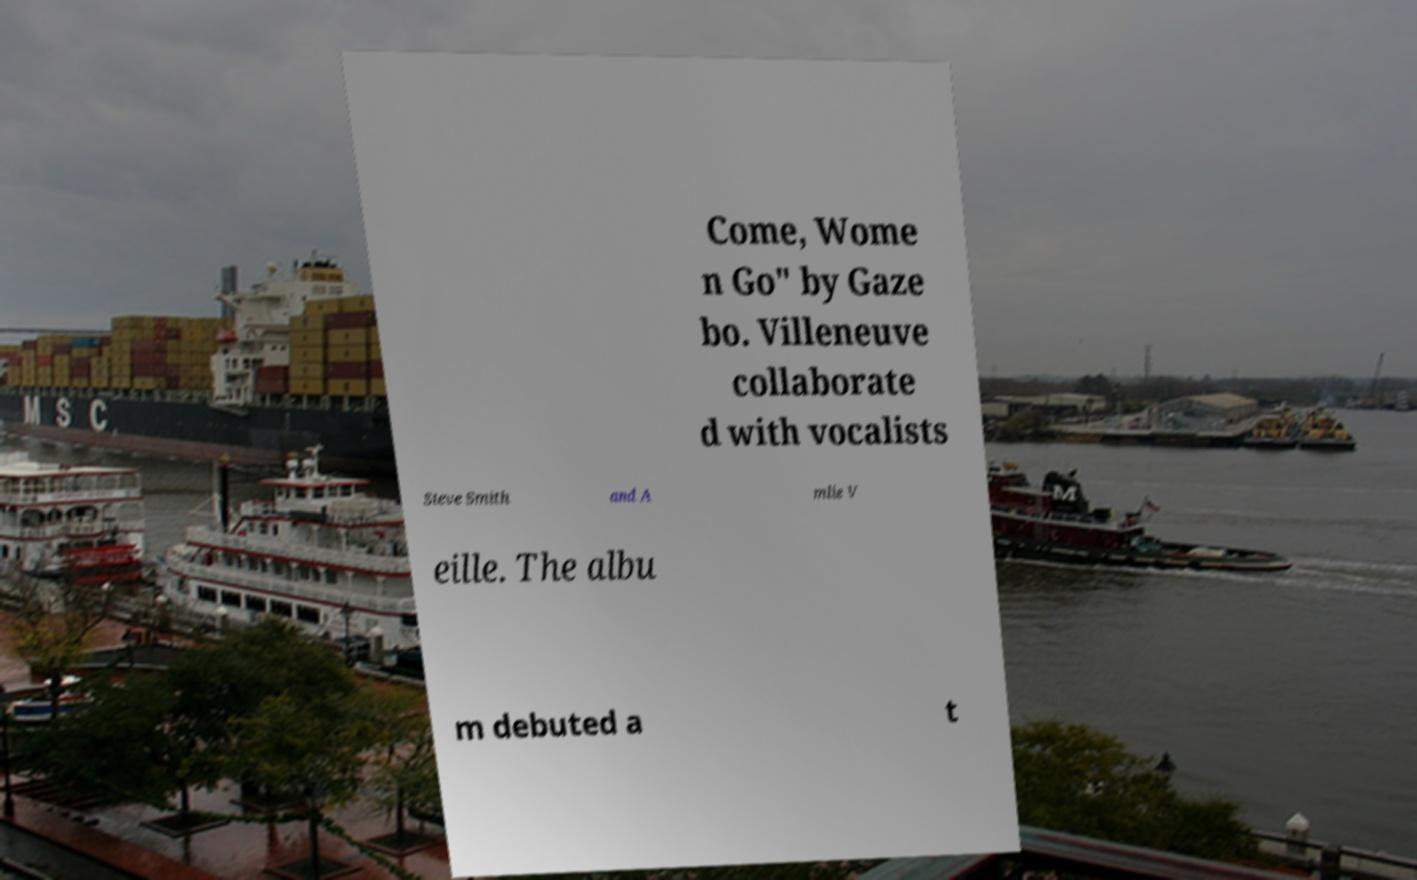Can you read and provide the text displayed in the image?This photo seems to have some interesting text. Can you extract and type it out for me? Come, Wome n Go" by Gaze bo. Villeneuve collaborate d with vocalists Steve Smith and A mlie V eille. The albu m debuted a t 